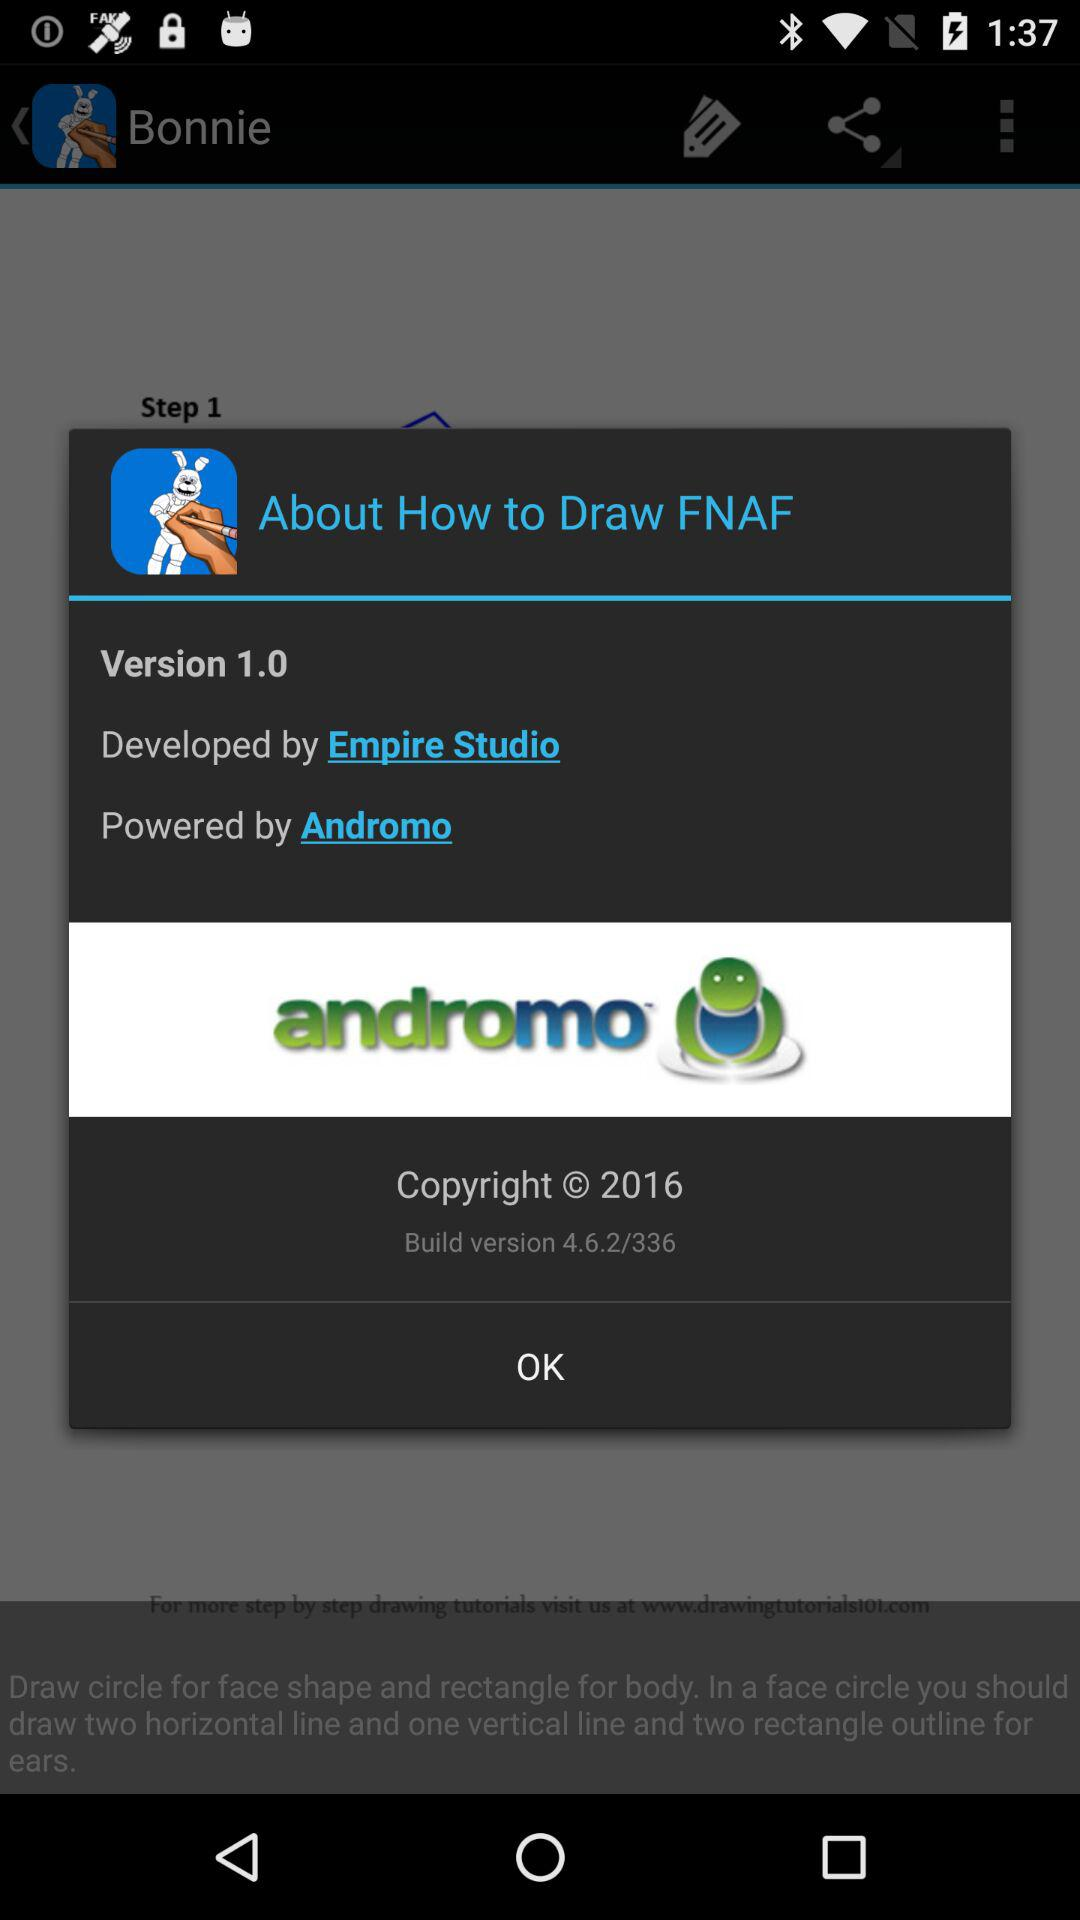What is the copyright year? The copyright year is 2016. 